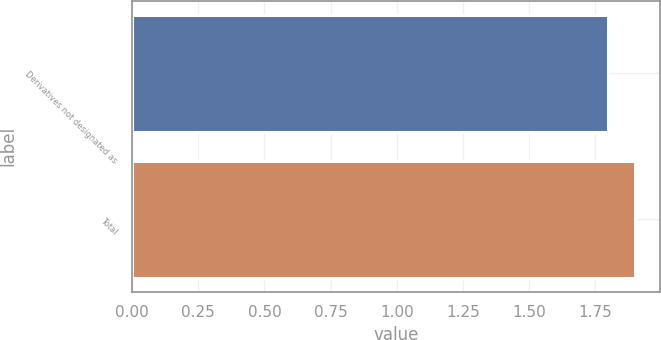<chart> <loc_0><loc_0><loc_500><loc_500><bar_chart><fcel>Derivatives not designated as<fcel>Total<nl><fcel>1.8<fcel>1.9<nl></chart> 